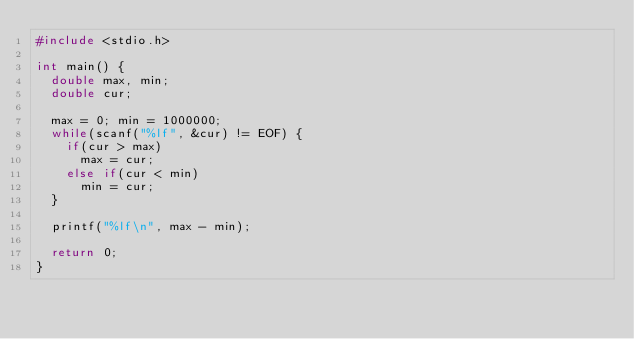<code> <loc_0><loc_0><loc_500><loc_500><_C_>#include <stdio.h>

int main() {
	double max, min;
	double cur;

	max = 0; min = 1000000;
	while(scanf("%lf", &cur) != EOF) {
		if(cur > max)
			max = cur;
		else if(cur < min)
			min = cur;
	}

	printf("%lf\n", max - min);

	return 0;
}</code> 